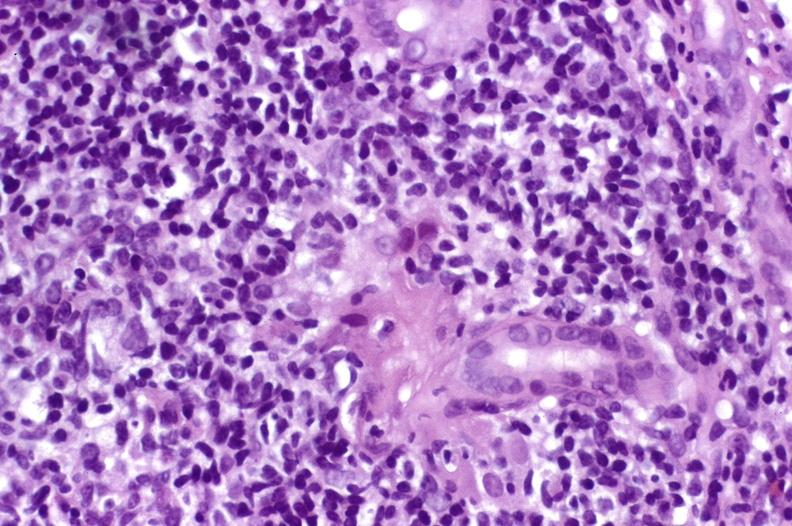does this image show recurrent hepatitis c virus?
Answer the question using a single word or phrase. Yes 